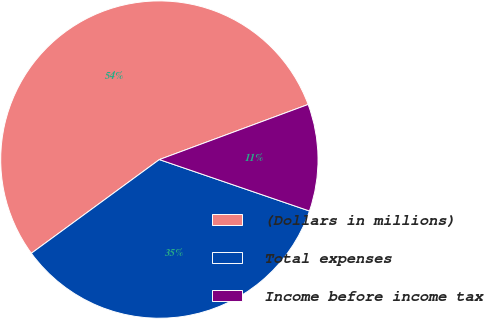Convert chart. <chart><loc_0><loc_0><loc_500><loc_500><pie_chart><fcel>(Dollars in millions)<fcel>Total expenses<fcel>Income before income tax<nl><fcel>54.41%<fcel>34.69%<fcel>10.9%<nl></chart> 